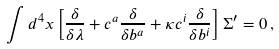Convert formula to latex. <formula><loc_0><loc_0><loc_500><loc_500>\int d ^ { 4 } x \left [ \frac { \delta } { \delta \lambda } + c ^ { a } \frac { \delta } { \delta b ^ { a } } + \kappa c ^ { i } \frac { \delta } { \delta b ^ { i } } \right ] \Sigma ^ { \prime } = 0 \, ,</formula> 